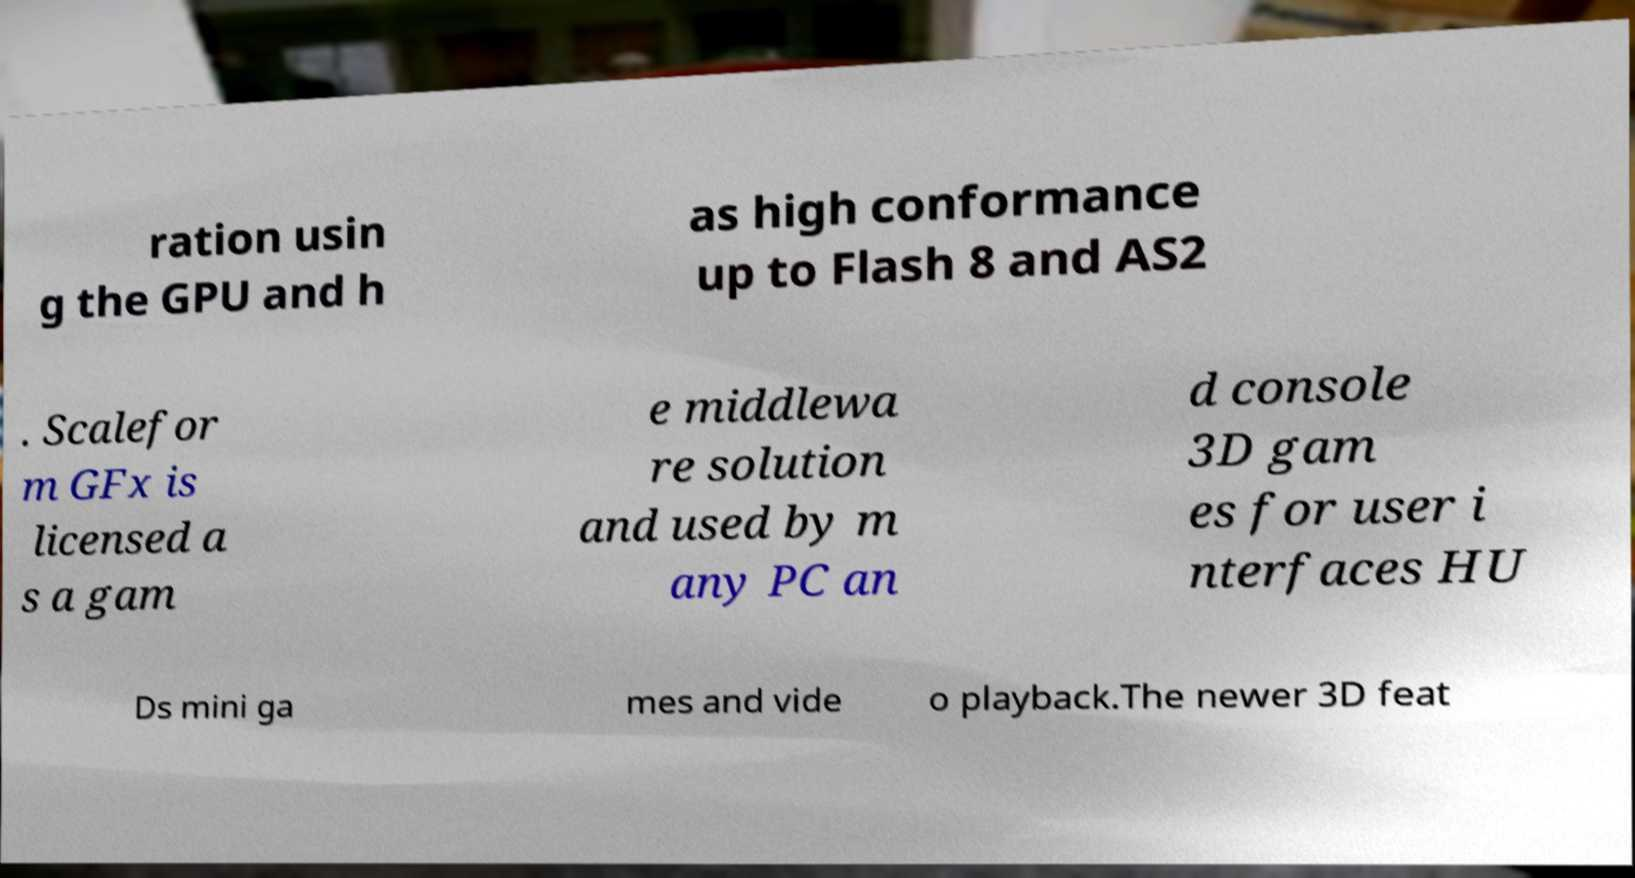Could you extract and type out the text from this image? ration usin g the GPU and h as high conformance up to Flash 8 and AS2 . Scalefor m GFx is licensed a s a gam e middlewa re solution and used by m any PC an d console 3D gam es for user i nterfaces HU Ds mini ga mes and vide o playback.The newer 3D feat 